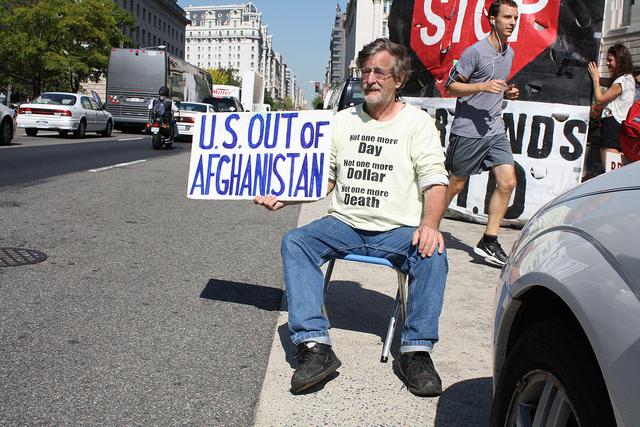What kind of pants does the seated man have on?
Be succinct. Jeans. What is on the man's knee?
Keep it brief. Hand. What does the man's sign read?
Quick response, please. Us out of afghanistan. 